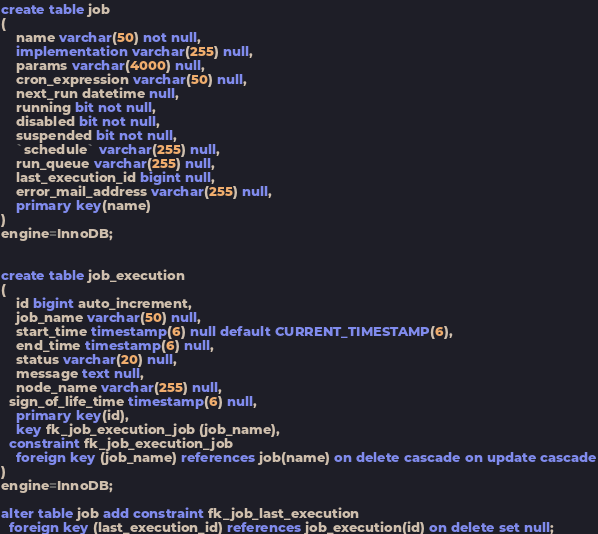<code> <loc_0><loc_0><loc_500><loc_500><_SQL_>create table job
(
	name varchar(50) not null,
	implementation varchar(255) null,
	params varchar(4000) null,
	cron_expression varchar(50) null,
	next_run datetime null,
	running bit not null,
	disabled bit not null,
	suspended bit not null,
	`schedule` varchar(255) null,
	run_queue varchar(255) null,
	last_execution_id bigint null,
	error_mail_address varchar(255) null,
	primary key(name)
)
engine=InnoDB;


create table job_execution
(
	id bigint auto_increment,
	job_name varchar(50) null,
	start_time timestamp(6) null default CURRENT_TIMESTAMP(6),
	end_time timestamp(6) null,
	status varchar(20) null,
	message text null,
	node_name varchar(255) null,
  sign_of_life_time timestamp(6) null,
	primary key(id),
	key fk_job_execution_job (job_name),
  constraint fk_job_execution_job
    foreign key (job_name) references job(name) on delete cascade on update cascade
)
engine=InnoDB;

alter table job add constraint fk_job_last_execution
  foreign key (last_execution_id) references job_execution(id) on delete set null;

</code> 